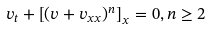<formula> <loc_0><loc_0><loc_500><loc_500>v _ { t } + \left [ ( v + v _ { x x } ) ^ { n } \right ] _ { x } = 0 , n \geq 2</formula> 